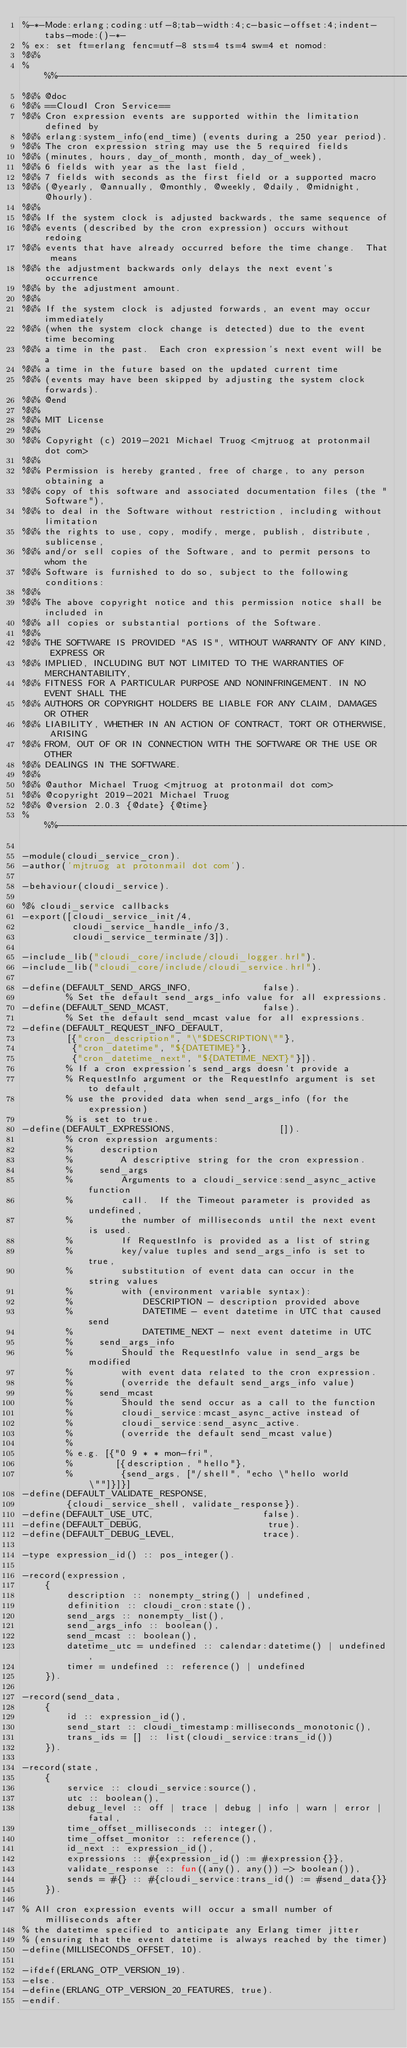<code> <loc_0><loc_0><loc_500><loc_500><_Erlang_>%-*-Mode:erlang;coding:utf-8;tab-width:4;c-basic-offset:4;indent-tabs-mode:()-*-
% ex: set ft=erlang fenc=utf-8 sts=4 ts=4 sw=4 et nomod:
%%%
%%%------------------------------------------------------------------------
%%% @doc
%%% ==CloudI Cron Service==
%%% Cron expression events are supported within the limitation defined by
%%% erlang:system_info(end_time) (events during a 250 year period).
%%% The cron expression string may use the 5 required fields
%%% (minutes, hours, day_of_month, month, day_of_week),
%%% 6 fields with year as the last field,
%%% 7 fields with seconds as the first field or a supported macro
%%% (@yearly, @annually, @monthly, @weekly, @daily, @midnight, @hourly).
%%%
%%% If the system clock is adjusted backwards, the same sequence of
%%% events (described by the cron expression) occurs without redoing
%%% events that have already occurred before the time change.  That means
%%% the adjustment backwards only delays the next event's occurrence
%%% by the adjustment amount.
%%%
%%% If the system clock is adjusted forwards, an event may occur immediately
%%% (when the system clock change is detected) due to the event time becoming
%%% a time in the past.  Each cron expression's next event will be a
%%% a time in the future based on the updated current time
%%% (events may have been skipped by adjusting the system clock forwards).
%%% @end
%%%
%%% MIT License
%%%
%%% Copyright (c) 2019-2021 Michael Truog <mjtruog at protonmail dot com>
%%%
%%% Permission is hereby granted, free of charge, to any person obtaining a
%%% copy of this software and associated documentation files (the "Software"),
%%% to deal in the Software without restriction, including without limitation
%%% the rights to use, copy, modify, merge, publish, distribute, sublicense,
%%% and/or sell copies of the Software, and to permit persons to whom the
%%% Software is furnished to do so, subject to the following conditions:
%%%
%%% The above copyright notice and this permission notice shall be included in
%%% all copies or substantial portions of the Software.
%%%
%%% THE SOFTWARE IS PROVIDED "AS IS", WITHOUT WARRANTY OF ANY KIND, EXPRESS OR
%%% IMPLIED, INCLUDING BUT NOT LIMITED TO THE WARRANTIES OF MERCHANTABILITY,
%%% FITNESS FOR A PARTICULAR PURPOSE AND NONINFRINGEMENT. IN NO EVENT SHALL THE
%%% AUTHORS OR COPYRIGHT HOLDERS BE LIABLE FOR ANY CLAIM, DAMAGES OR OTHER
%%% LIABILITY, WHETHER IN AN ACTION OF CONTRACT, TORT OR OTHERWISE, ARISING
%%% FROM, OUT OF OR IN CONNECTION WITH THE SOFTWARE OR THE USE OR OTHER
%%% DEALINGS IN THE SOFTWARE.
%%%
%%% @author Michael Truog <mjtruog at protonmail dot com>
%%% @copyright 2019-2021 Michael Truog
%%% @version 2.0.3 {@date} {@time}
%%%------------------------------------------------------------------------

-module(cloudi_service_cron).
-author('mjtruog at protonmail dot com').

-behaviour(cloudi_service).

%% cloudi_service callbacks
-export([cloudi_service_init/4,
         cloudi_service_handle_info/3,
         cloudi_service_terminate/3]).

-include_lib("cloudi_core/include/cloudi_logger.hrl").
-include_lib("cloudi_core/include/cloudi_service.hrl").

-define(DEFAULT_SEND_ARGS_INFO,             false).
        % Set the default send_args_info value for all expressions.
-define(DEFAULT_SEND_MCAST,                 false).
        % Set the default send_mcast value for all expressions.
-define(DEFAULT_REQUEST_INFO_DEFAULT,
        [{"cron_description", "\"$DESCRIPTION\""},
         {"cron_datetime", "${DATETIME}"},
         {"cron_datetime_next", "${DATETIME_NEXT}"}]).
        % If a cron expression's send_args doesn't provide a
        % RequestInfo argument or the RequestInfo argument is set to default,
        % use the provided data when send_args_info (for the expression)
        % is set to true.
-define(DEFAULT_EXPRESSIONS,                   []).
        % cron expression arguments:
        %     description
        %         A descriptive string for the cron expression.
        %     send_args
        %         Arguments to a cloudi_service:send_async_active function
        %         call.  If the Timeout parameter is provided as undefined,
        %         the number of milliseconds until the next event is used.
        %         If RequestInfo is provided as a list of string
        %         key/value tuples and send_args_info is set to true,
        %         substitution of event data can occur in the string values
        %         with (environment variable syntax):
        %             DESCRIPTION - description provided above
        %             DATETIME - event datetime in UTC that caused send
        %             DATETIME_NEXT - next event datetime in UTC
        %     send_args_info
        %         Should the RequestInfo value in send_args be modified
        %         with event data related to the cron expression.
        %         (override the default send_args_info value)
        %     send_mcast
        %         Should the send occur as a call to the function
        %         cloudi_service:mcast_async_active instead of
        %         cloudi_service:send_async_active.
        %         (override the default send_mcast value)
        %
        % e.g. [{"0 9 * * mon-fri",
        %        [{description, "hello"},
        %         {send_args, ["/shell", "echo \"hello world\""]}]}]
-define(DEFAULT_VALIDATE_RESPONSE,
        {cloudi_service_shell, validate_response}).
-define(DEFAULT_USE_UTC,                    false).
-define(DEFAULT_DEBUG,                       true).
-define(DEFAULT_DEBUG_LEVEL,                trace).

-type expression_id() :: pos_integer().

-record(expression,
    {
        description :: nonempty_string() | undefined,
        definition :: cloudi_cron:state(),
        send_args :: nonempty_list(),
        send_args_info :: boolean(),
        send_mcast :: boolean(),
        datetime_utc = undefined :: calendar:datetime() | undefined,
        timer = undefined :: reference() | undefined
    }).

-record(send_data,
    {
        id :: expression_id(),
        send_start :: cloudi_timestamp:milliseconds_monotonic(),
        trans_ids = [] :: list(cloudi_service:trans_id())
    }).

-record(state,
    {
        service :: cloudi_service:source(),
        utc :: boolean(),
        debug_level :: off | trace | debug | info | warn | error | fatal,
        time_offset_milliseconds :: integer(),
        time_offset_monitor :: reference(),
        id_next :: expression_id(),
        expressions :: #{expression_id() := #expression{}},
        validate_response :: fun((any(), any()) -> boolean()),
        sends = #{} :: #{cloudi_service:trans_id() := #send_data{}}
    }).

% All cron expression events will occur a small number of milliseconds after
% the datetime specified to anticipate any Erlang timer jitter
% (ensuring that the event datetime is always reached by the timer)
-define(MILLISECONDS_OFFSET, 10).

-ifdef(ERLANG_OTP_VERSION_19).
-else.
-define(ERLANG_OTP_VERSION_20_FEATURES, true).
-endif.
</code> 